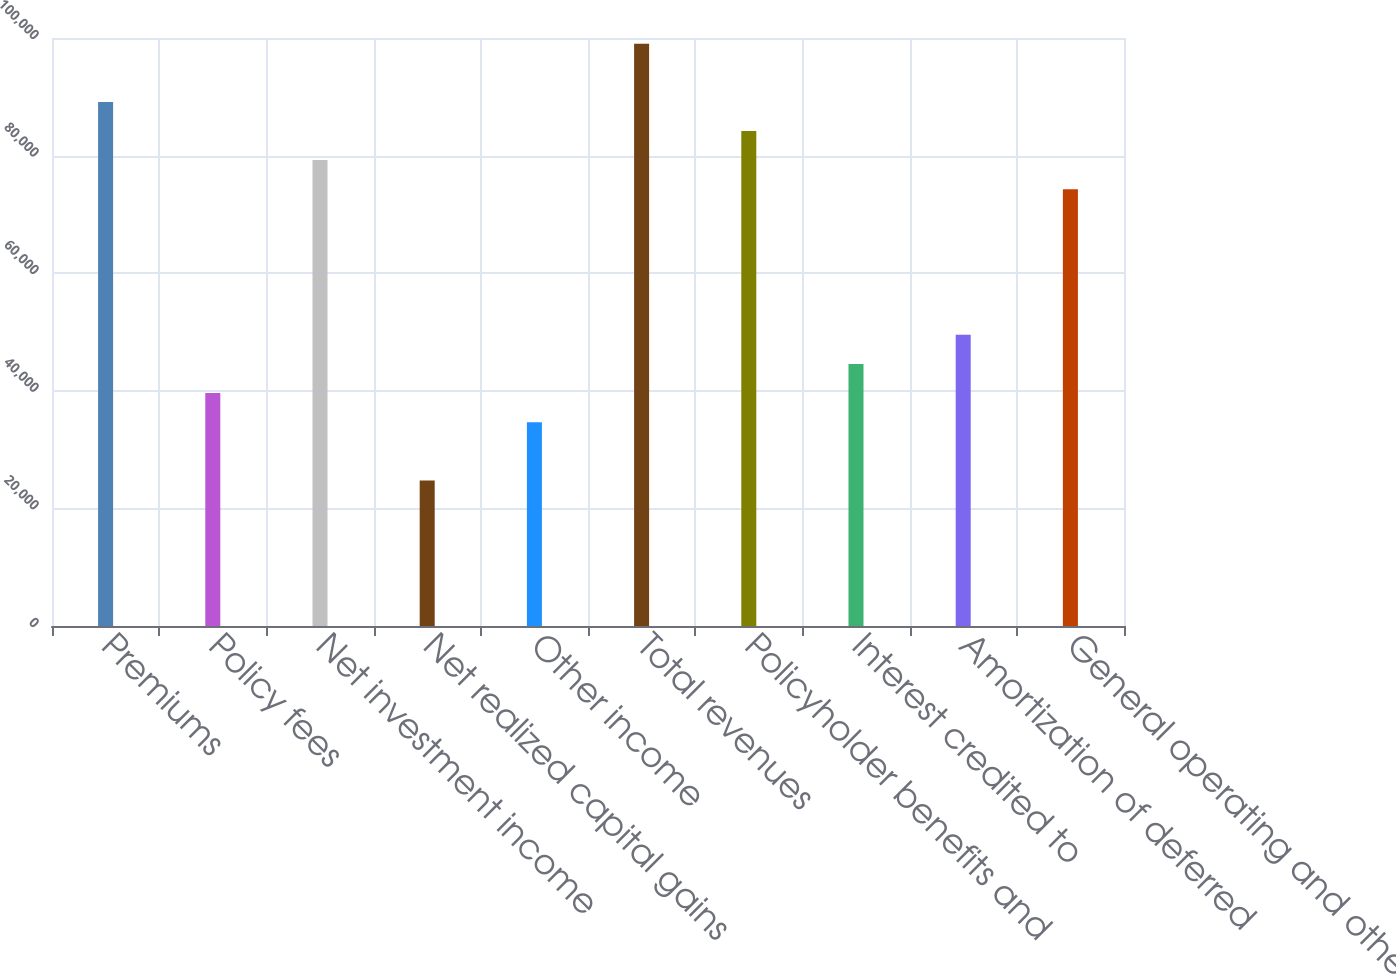Convert chart to OTSL. <chart><loc_0><loc_0><loc_500><loc_500><bar_chart><fcel>Premiums<fcel>Policy fees<fcel>Net investment income<fcel>Net realized capital gains<fcel>Other income<fcel>Total revenues<fcel>Policyholder benefits and<fcel>Interest credited to<fcel>Amortization of deferred<fcel>General operating and other<nl><fcel>89134.9<fcel>39616.2<fcel>79231.2<fcel>24760.6<fcel>34664.4<fcel>99038.7<fcel>84183.1<fcel>44568.1<fcel>49520<fcel>74279.3<nl></chart> 